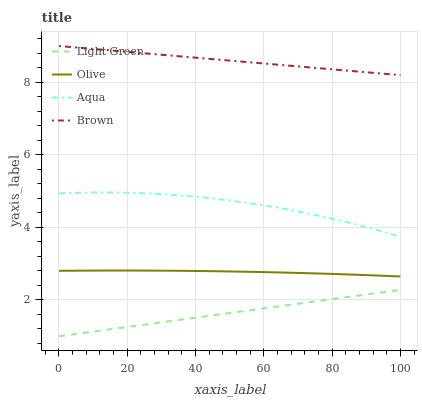Does Light Green have the minimum area under the curve?
Answer yes or no. Yes. Does Brown have the maximum area under the curve?
Answer yes or no. Yes. Does Aqua have the minimum area under the curve?
Answer yes or no. No. Does Aqua have the maximum area under the curve?
Answer yes or no. No. Is Light Green the smoothest?
Answer yes or no. Yes. Is Aqua the roughest?
Answer yes or no. Yes. Is Brown the smoothest?
Answer yes or no. No. Is Brown the roughest?
Answer yes or no. No. Does Light Green have the lowest value?
Answer yes or no. Yes. Does Aqua have the lowest value?
Answer yes or no. No. Does Brown have the highest value?
Answer yes or no. Yes. Does Aqua have the highest value?
Answer yes or no. No. Is Olive less than Aqua?
Answer yes or no. Yes. Is Aqua greater than Olive?
Answer yes or no. Yes. Does Olive intersect Aqua?
Answer yes or no. No. 